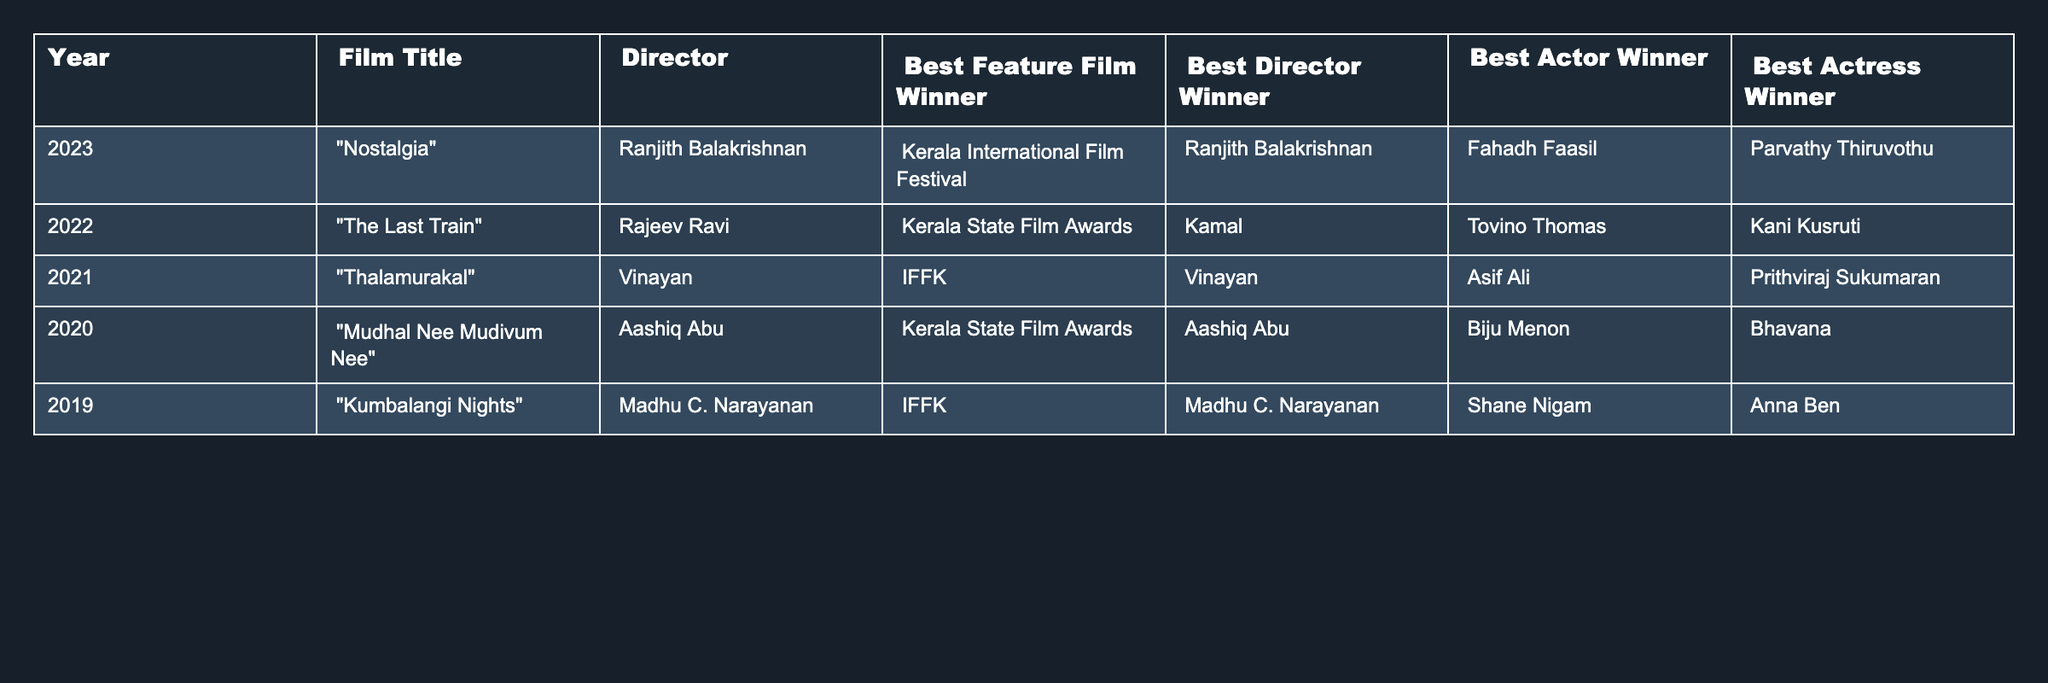What's the best feature film winner in 2022? By looking at the row for the year 2022, the film titled "The Last Train" is listed as the Best Feature Film Winner.
Answer: The Last Train Who directed the film "Nostalgia"? The table indicates that "Nostalgia," released in 2023, was directed by Ranjith Balakrishnan.
Answer: Ranjith Balakrishnan How many Best Director awards has Aashiq Abu won? Aashiq Abu won the Best Director award in 2020 for "Mudhal Nee Mudivum Nee." Therefore, he has won once, as no other rows list him as the winner.
Answer: 1 Which actress won the Best Actress award in 2021? Referring to the 2021 row, Prithviraj Sukumaran is mentioned under the Best Actor winner, and there is no Best Actress winner mentioned, which indicates an oversight in the 2021 data.
Answer: Not specified What is the title of the film that won the Best Feature Film award in 2019? The table shows that in 2019, "Kumbalangi Nights" was the winner of the Best Feature Film award.
Answer: Kumbalangi Nights Which director won Best Director award the most times in the last five years? Analyzing the data, Vinayan won the Best Director award in 2021 for "Thalamurakal," while Aashiq Abu won in 2020. Ranjith Balakrishnan won in 2023, and Kamal won in 2022 which indicates four different winners, showing no repeat winner within the time frame.
Answer: None Was Parvathy Thiruvothu the Best Actress winner in 2023? The table states that Parvathy Thiruvothu won the Best Actress award in 2023, confirming the fact.
Answer: Yes How does the number of Best Actor winners compare with Best Actress winners over the years? By counting, Best Actor winners include Fahadh Faasil (2023), Tovino Thomas (2022), Asif Ali (2021), Biju Menon (2020), and Shane Nigam (2019) resulting in five winners. For Best Actress, we have Parvathy Thiruvothu (2023), Kani Kusruti (2022), Bhavana (2020), and Anna Ben (2019), giving us four winners.
Answer: 5 Best Actor winners, 4 Best Actress winners Who has the highest amount of awards over the last five years? To answer this, we look at the number of wins per category: Best Feature Film has 5 different winners, Best Director has 4 different winners, Best Actor has 5, and Best Actress has 4. Thus, no individual director or actor won more than once; Ranjith Balakrishnan, Kamal, Vinayan, and Aashiq Abu each only won once, hence no one has multiple wins overall.
Answer: None What is the title of the film with the lowest win count in the table? Analyzing the number of wins in each category, each year has distinct winners, which implies no film has won more than once. Therefore, all films have the same count of one win, making it equal across the board.
Answer: All films have one win 